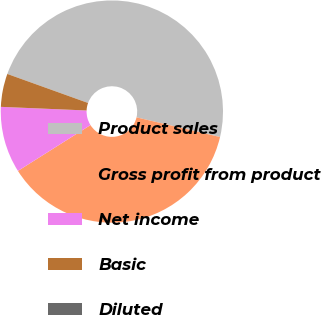Convert chart to OTSL. <chart><loc_0><loc_0><loc_500><loc_500><pie_chart><fcel>Product sales<fcel>Gross profit from product<fcel>Net income<fcel>Basic<fcel>Diluted<nl><fcel>48.18%<fcel>37.35%<fcel>9.64%<fcel>4.82%<fcel>0.0%<nl></chart> 